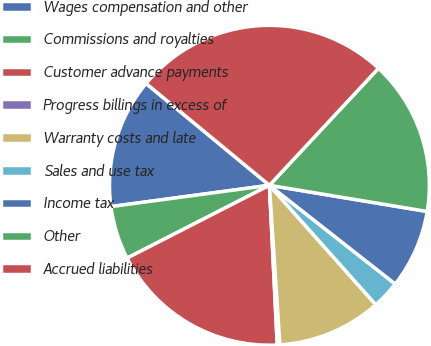Convert chart. <chart><loc_0><loc_0><loc_500><loc_500><pie_chart><fcel>Wages compensation and other<fcel>Commissions and royalties<fcel>Customer advance payments<fcel>Progress billings in excess of<fcel>Warranty costs and late<fcel>Sales and use tax<fcel>Income tax<fcel>Other<fcel>Accrued liabilities<nl><fcel>13.11%<fcel>5.4%<fcel>18.25%<fcel>0.26%<fcel>10.54%<fcel>2.83%<fcel>7.97%<fcel>15.68%<fcel>25.96%<nl></chart> 